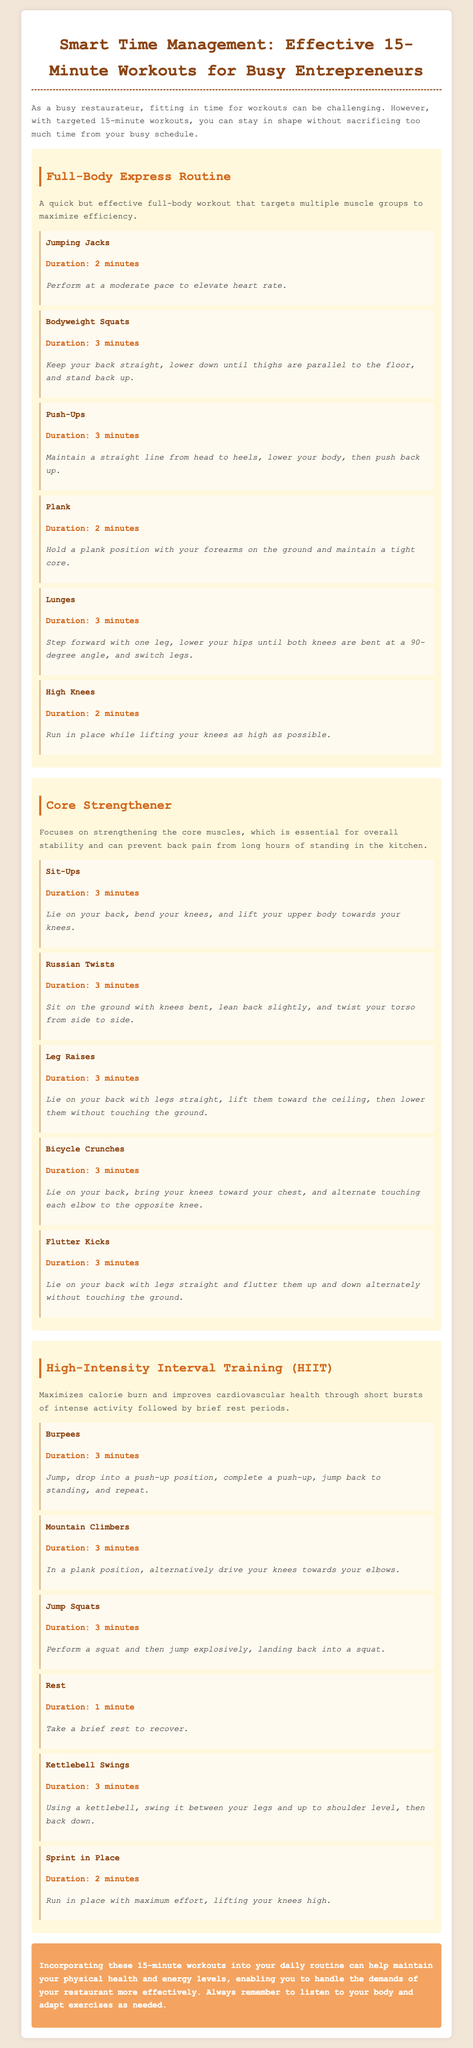What is the title of the document? The title of the document is found in the header of the page.
Answer: Smart Time Management: Effective 15-Minute Workouts for Busy Entrepreneurs How long is the duration for Jumping Jacks? The duration for Jumping Jacks is specified in the exercise section of the workout plan.
Answer: 2 minutes What is the total duration of the Full-Body Express Routine? The total duration is calculated by adding the individual exercise durations together.
Answer: 15 minutes Which workout focuses on core strengthening? The workout plan includes specific titles for each routine, identifying their focus areas.
Answer: Core Strengthener How many exercises are listed in the High-Intensity Interval Training section? The number of exercises is determined by counting each exercise within the HIIT section.
Answer: 6 What type of exercise are Burpees classified as? Exercises are categorized based on their intensity and focus in the workout plan.
Answer: High-Intensity Interval Training What is the duration of the rest period in the HIIT workout? The rest duration is explicitly mentioned alongside the related exercise in the workout plan.
Answer: 1 minute 